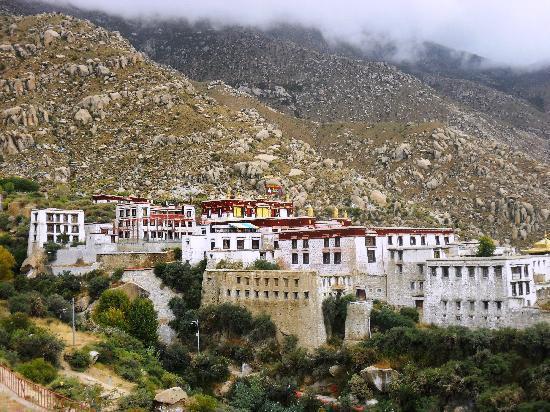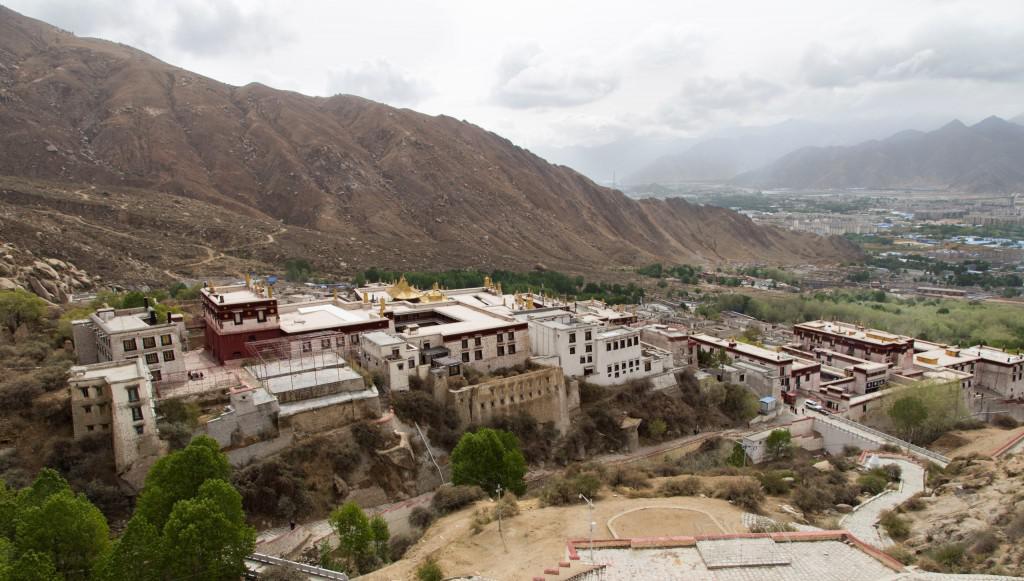The first image is the image on the left, the second image is the image on the right. For the images shown, is this caption "We see at least one mansion, built onto a skinny cliff; there certainly isn't enough room for a town." true? Answer yes or no. No. The first image is the image on the left, the second image is the image on the right. Considering the images on both sides, is "There are a set of red brick topped buildings sitting on the edge of a cliff." valid? Answer yes or no. No. 